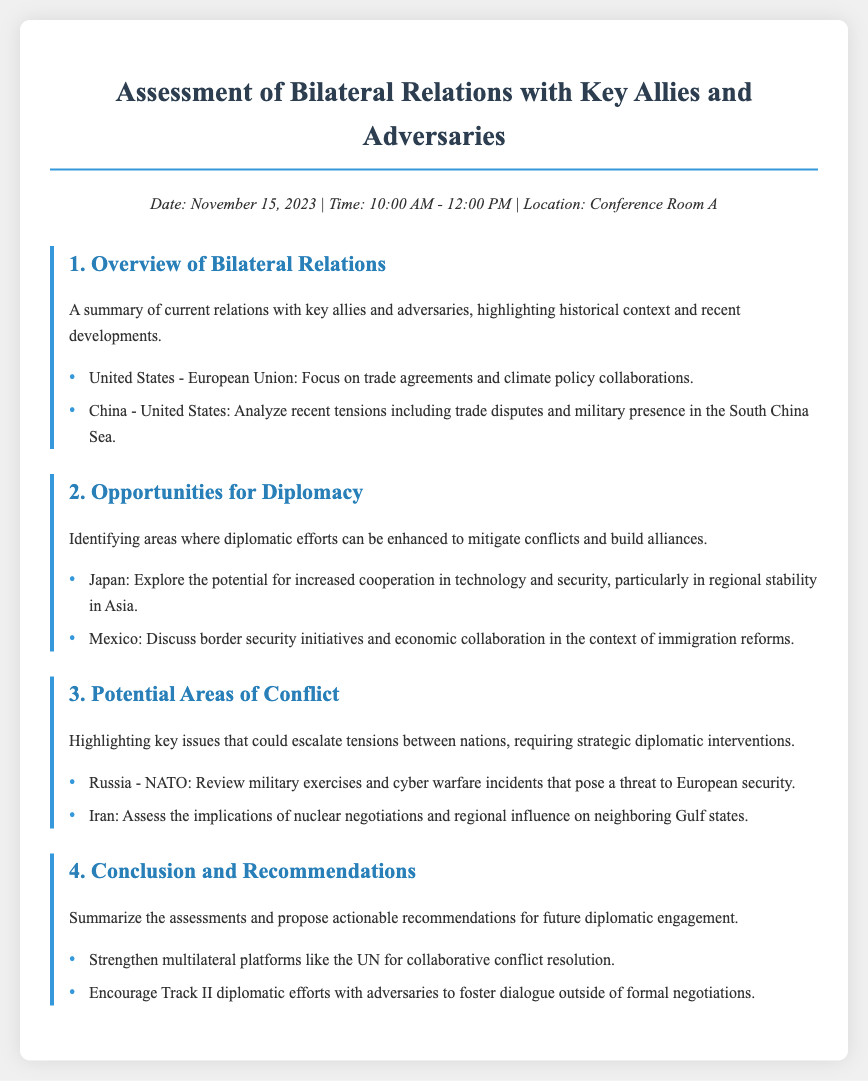What is the date of the meeting? The date of the meeting is specified in the header information of the document.
Answer: November 15, 2023 What time is the meeting scheduled to start? The time of the meeting is detailed in the header information.
Answer: 10:00 AM What is one key area of focus for US-European Union relations? A specific area of focus is provided under the overview of bilateral relations section.
Answer: Trade agreements Which two countries are mentioned in connection with recent tensions? Recent tensions are discussed in the overview section of the document.
Answer: China and United States What opportunity for diplomacy is suggested concerning Japan? The opportunities for diplomacy highlight potential areas of cooperation.
Answer: Technology and security Which military alliance is mentioned in the potential areas of conflict? A military alliance is specified in the section discussing potential areas of conflict.
Answer: NATO What are the implications highlighted regarding Iran? The document mentions a specific concern about Iran in the potential conflict section.
Answer: Nuclear negotiations What recommendation is made concerning the United Nations? Recommendations for future diplomatic engagement include strategies mentioned in the conclusion section.
Answer: Strengthen multilateral platforms How many agenda items are listed in the document? The total number of agenda items can be counted directly in the document structure.
Answer: Four 